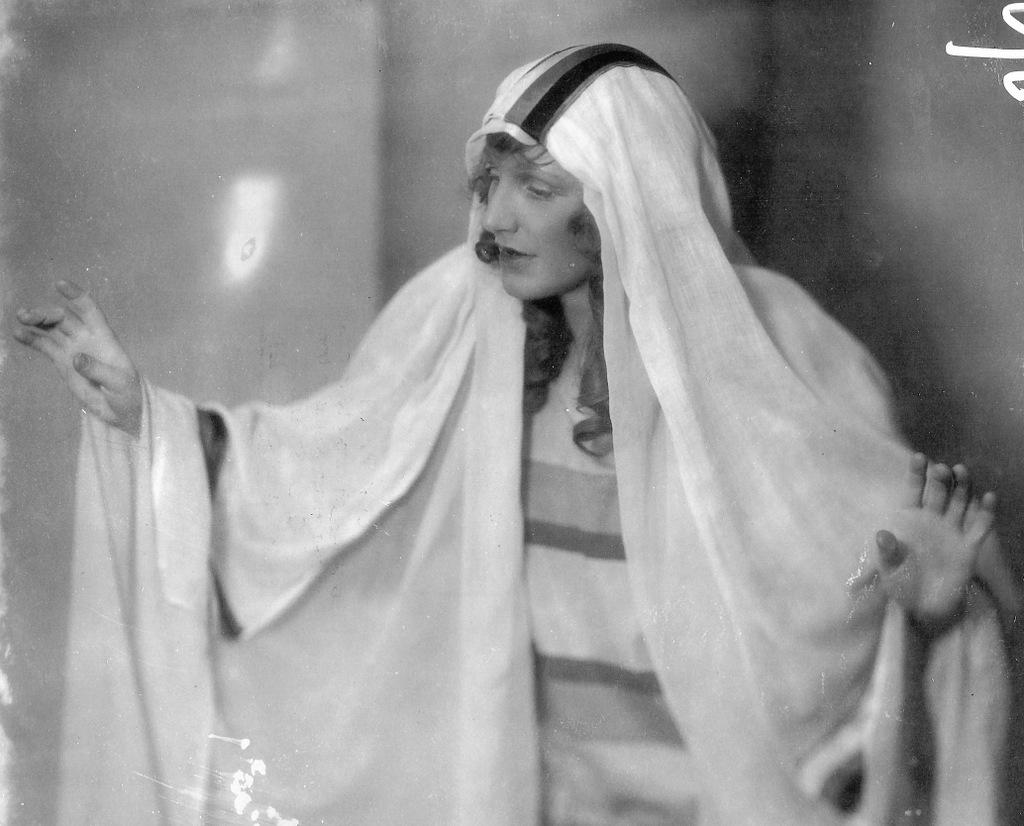What is the color scheme of the image? The image is black and white. What can be seen in the foreground of the image? There is a woman standing in the image. What is visible in the background of the image? There is a wall behind the woman. What is the woman's annual income in the image? There is no information about the woman's income in the image. Does the woman appear to be experiencing any shame in the image? There is no indication of the woman's emotions or feelings in the image. 